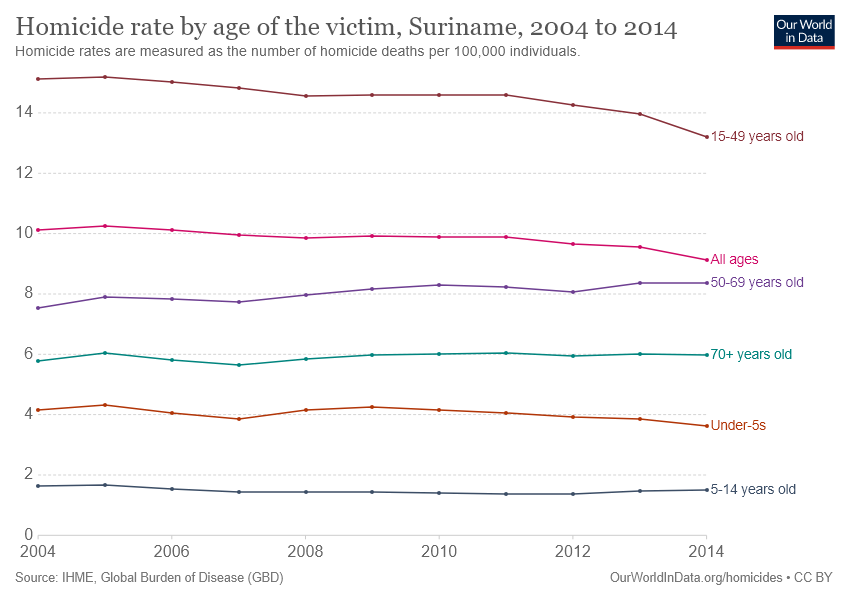Give some essential details in this illustration. According to recorded data, three age groups have had a suicide rate of more than 6 in the past years. The 15-49 year age group recorded the highest homicide rate in Suriname over the years. 